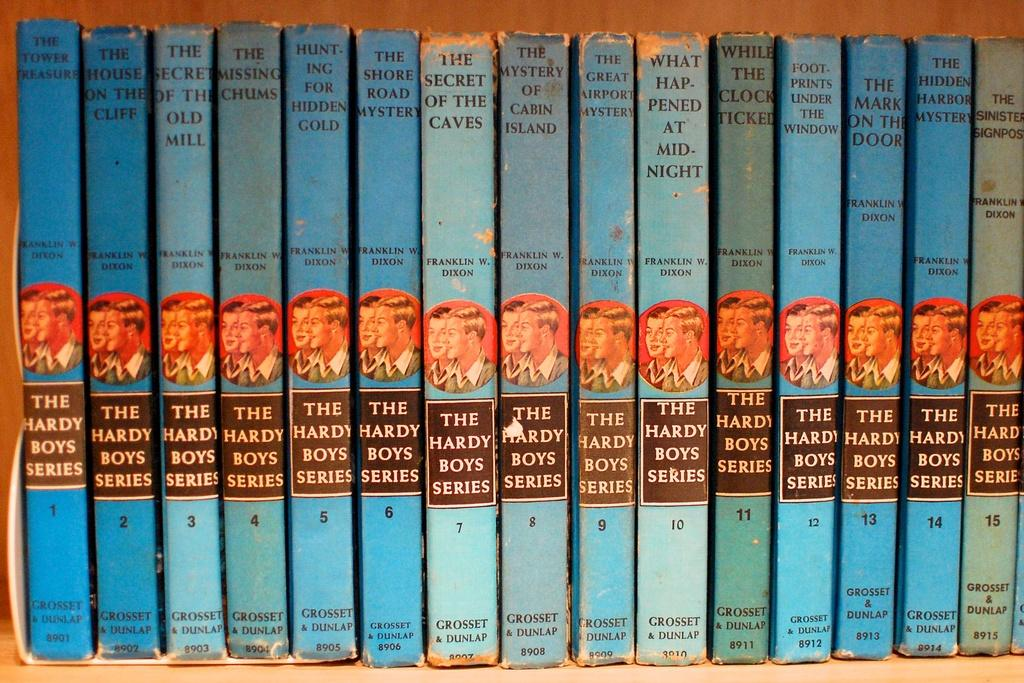<image>
Summarize the visual content of the image. A bookshelf filled with The Hardy Boys series books. 